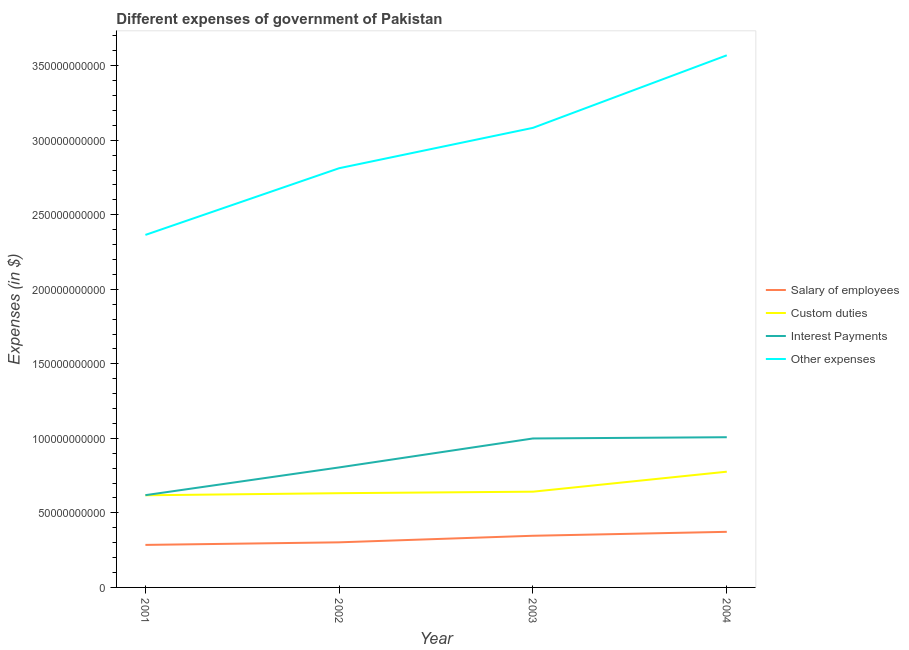How many different coloured lines are there?
Your answer should be very brief. 4. Does the line corresponding to amount spent on custom duties intersect with the line corresponding to amount spent on interest payments?
Provide a succinct answer. No. What is the amount spent on salary of employees in 2002?
Your answer should be very brief. 3.03e+1. Across all years, what is the maximum amount spent on custom duties?
Your answer should be very brief. 7.77e+1. Across all years, what is the minimum amount spent on other expenses?
Provide a short and direct response. 2.37e+11. In which year was the amount spent on other expenses maximum?
Offer a terse response. 2004. In which year was the amount spent on other expenses minimum?
Offer a very short reply. 2001. What is the total amount spent on salary of employees in the graph?
Your answer should be very brief. 1.31e+11. What is the difference between the amount spent on other expenses in 2001 and that in 2002?
Provide a short and direct response. -4.48e+1. What is the difference between the amount spent on other expenses in 2002 and the amount spent on custom duties in 2004?
Offer a terse response. 2.04e+11. What is the average amount spent on salary of employees per year?
Give a very brief answer. 3.27e+1. In the year 2001, what is the difference between the amount spent on other expenses and amount spent on interest payments?
Offer a terse response. 1.75e+11. In how many years, is the amount spent on salary of employees greater than 40000000000 $?
Make the answer very short. 0. What is the ratio of the amount spent on other expenses in 2001 to that in 2002?
Provide a short and direct response. 0.84. Is the amount spent on salary of employees in 2003 less than that in 2004?
Your answer should be very brief. Yes. What is the difference between the highest and the second highest amount spent on interest payments?
Offer a very short reply. 8.32e+08. What is the difference between the highest and the lowest amount spent on interest payments?
Keep it short and to the point. 3.89e+1. Is it the case that in every year, the sum of the amount spent on salary of employees and amount spent on custom duties is greater than the amount spent on interest payments?
Your answer should be very brief. No. Does the amount spent on custom duties monotonically increase over the years?
Provide a short and direct response. Yes. Is the amount spent on interest payments strictly less than the amount spent on custom duties over the years?
Provide a short and direct response. No. How many lines are there?
Offer a terse response. 4. How many years are there in the graph?
Provide a succinct answer. 4. Are the values on the major ticks of Y-axis written in scientific E-notation?
Your response must be concise. No. How many legend labels are there?
Give a very brief answer. 4. How are the legend labels stacked?
Offer a terse response. Vertical. What is the title of the graph?
Your answer should be compact. Different expenses of government of Pakistan. What is the label or title of the X-axis?
Your answer should be very brief. Year. What is the label or title of the Y-axis?
Provide a succinct answer. Expenses (in $). What is the Expenses (in $) of Salary of employees in 2001?
Keep it short and to the point. 2.85e+1. What is the Expenses (in $) of Custom duties in 2001?
Offer a terse response. 6.18e+1. What is the Expenses (in $) in Interest Payments in 2001?
Offer a very short reply. 6.19e+1. What is the Expenses (in $) in Other expenses in 2001?
Your answer should be very brief. 2.37e+11. What is the Expenses (in $) in Salary of employees in 2002?
Make the answer very short. 3.03e+1. What is the Expenses (in $) in Custom duties in 2002?
Your answer should be very brief. 6.32e+1. What is the Expenses (in $) in Interest Payments in 2002?
Make the answer very short. 8.05e+1. What is the Expenses (in $) in Other expenses in 2002?
Your answer should be very brief. 2.81e+11. What is the Expenses (in $) in Salary of employees in 2003?
Offer a terse response. 3.47e+1. What is the Expenses (in $) of Custom duties in 2003?
Your answer should be compact. 6.42e+1. What is the Expenses (in $) in Interest Payments in 2003?
Keep it short and to the point. 9.99e+1. What is the Expenses (in $) of Other expenses in 2003?
Your response must be concise. 3.08e+11. What is the Expenses (in $) of Salary of employees in 2004?
Your answer should be very brief. 3.73e+1. What is the Expenses (in $) of Custom duties in 2004?
Make the answer very short. 7.77e+1. What is the Expenses (in $) of Interest Payments in 2004?
Give a very brief answer. 1.01e+11. What is the Expenses (in $) in Other expenses in 2004?
Offer a terse response. 3.57e+11. Across all years, what is the maximum Expenses (in $) of Salary of employees?
Offer a terse response. 3.73e+1. Across all years, what is the maximum Expenses (in $) of Custom duties?
Give a very brief answer. 7.77e+1. Across all years, what is the maximum Expenses (in $) in Interest Payments?
Give a very brief answer. 1.01e+11. Across all years, what is the maximum Expenses (in $) in Other expenses?
Give a very brief answer. 3.57e+11. Across all years, what is the minimum Expenses (in $) in Salary of employees?
Your response must be concise. 2.85e+1. Across all years, what is the minimum Expenses (in $) in Custom duties?
Give a very brief answer. 6.18e+1. Across all years, what is the minimum Expenses (in $) of Interest Payments?
Your answer should be compact. 6.19e+1. Across all years, what is the minimum Expenses (in $) of Other expenses?
Your answer should be very brief. 2.37e+11. What is the total Expenses (in $) of Salary of employees in the graph?
Your answer should be compact. 1.31e+11. What is the total Expenses (in $) in Custom duties in the graph?
Provide a succinct answer. 2.67e+11. What is the total Expenses (in $) in Interest Payments in the graph?
Keep it short and to the point. 3.43e+11. What is the total Expenses (in $) of Other expenses in the graph?
Your answer should be very brief. 1.18e+12. What is the difference between the Expenses (in $) in Salary of employees in 2001 and that in 2002?
Make the answer very short. -1.73e+09. What is the difference between the Expenses (in $) in Custom duties in 2001 and that in 2002?
Your answer should be very brief. -1.40e+09. What is the difference between the Expenses (in $) in Interest Payments in 2001 and that in 2002?
Provide a succinct answer. -1.86e+1. What is the difference between the Expenses (in $) in Other expenses in 2001 and that in 2002?
Give a very brief answer. -4.48e+1. What is the difference between the Expenses (in $) of Salary of employees in 2001 and that in 2003?
Your response must be concise. -6.14e+09. What is the difference between the Expenses (in $) in Custom duties in 2001 and that in 2003?
Your answer should be very brief. -2.42e+09. What is the difference between the Expenses (in $) of Interest Payments in 2001 and that in 2003?
Your response must be concise. -3.80e+1. What is the difference between the Expenses (in $) of Other expenses in 2001 and that in 2003?
Give a very brief answer. -7.18e+1. What is the difference between the Expenses (in $) in Salary of employees in 2001 and that in 2004?
Ensure brevity in your answer.  -8.78e+09. What is the difference between the Expenses (in $) in Custom duties in 2001 and that in 2004?
Provide a succinct answer. -1.58e+1. What is the difference between the Expenses (in $) in Interest Payments in 2001 and that in 2004?
Your response must be concise. -3.89e+1. What is the difference between the Expenses (in $) in Other expenses in 2001 and that in 2004?
Provide a succinct answer. -1.20e+11. What is the difference between the Expenses (in $) in Salary of employees in 2002 and that in 2003?
Ensure brevity in your answer.  -4.40e+09. What is the difference between the Expenses (in $) in Custom duties in 2002 and that in 2003?
Provide a succinct answer. -1.02e+09. What is the difference between the Expenses (in $) in Interest Payments in 2002 and that in 2003?
Your answer should be very brief. -1.94e+1. What is the difference between the Expenses (in $) in Other expenses in 2002 and that in 2003?
Your answer should be compact. -2.71e+1. What is the difference between the Expenses (in $) in Salary of employees in 2002 and that in 2004?
Your response must be concise. -7.04e+09. What is the difference between the Expenses (in $) in Custom duties in 2002 and that in 2004?
Give a very brief answer. -1.44e+1. What is the difference between the Expenses (in $) of Interest Payments in 2002 and that in 2004?
Provide a succinct answer. -2.03e+1. What is the difference between the Expenses (in $) of Other expenses in 2002 and that in 2004?
Ensure brevity in your answer.  -7.57e+1. What is the difference between the Expenses (in $) of Salary of employees in 2003 and that in 2004?
Your answer should be very brief. -2.64e+09. What is the difference between the Expenses (in $) of Custom duties in 2003 and that in 2004?
Offer a terse response. -1.34e+1. What is the difference between the Expenses (in $) of Interest Payments in 2003 and that in 2004?
Offer a terse response. -8.32e+08. What is the difference between the Expenses (in $) of Other expenses in 2003 and that in 2004?
Provide a short and direct response. -4.87e+1. What is the difference between the Expenses (in $) in Salary of employees in 2001 and the Expenses (in $) in Custom duties in 2002?
Offer a very short reply. -3.47e+1. What is the difference between the Expenses (in $) in Salary of employees in 2001 and the Expenses (in $) in Interest Payments in 2002?
Provide a succinct answer. -5.20e+1. What is the difference between the Expenses (in $) of Salary of employees in 2001 and the Expenses (in $) of Other expenses in 2002?
Your answer should be very brief. -2.53e+11. What is the difference between the Expenses (in $) in Custom duties in 2001 and the Expenses (in $) in Interest Payments in 2002?
Offer a very short reply. -1.87e+1. What is the difference between the Expenses (in $) of Custom duties in 2001 and the Expenses (in $) of Other expenses in 2002?
Give a very brief answer. -2.19e+11. What is the difference between the Expenses (in $) in Interest Payments in 2001 and the Expenses (in $) in Other expenses in 2002?
Give a very brief answer. -2.19e+11. What is the difference between the Expenses (in $) in Salary of employees in 2001 and the Expenses (in $) in Custom duties in 2003?
Your answer should be compact. -3.57e+1. What is the difference between the Expenses (in $) of Salary of employees in 2001 and the Expenses (in $) of Interest Payments in 2003?
Your answer should be compact. -7.14e+1. What is the difference between the Expenses (in $) in Salary of employees in 2001 and the Expenses (in $) in Other expenses in 2003?
Your response must be concise. -2.80e+11. What is the difference between the Expenses (in $) of Custom duties in 2001 and the Expenses (in $) of Interest Payments in 2003?
Offer a very short reply. -3.81e+1. What is the difference between the Expenses (in $) in Custom duties in 2001 and the Expenses (in $) in Other expenses in 2003?
Provide a short and direct response. -2.47e+11. What is the difference between the Expenses (in $) of Interest Payments in 2001 and the Expenses (in $) of Other expenses in 2003?
Your answer should be compact. -2.46e+11. What is the difference between the Expenses (in $) of Salary of employees in 2001 and the Expenses (in $) of Custom duties in 2004?
Provide a short and direct response. -4.91e+1. What is the difference between the Expenses (in $) in Salary of employees in 2001 and the Expenses (in $) in Interest Payments in 2004?
Offer a terse response. -7.22e+1. What is the difference between the Expenses (in $) in Salary of employees in 2001 and the Expenses (in $) in Other expenses in 2004?
Offer a terse response. -3.28e+11. What is the difference between the Expenses (in $) of Custom duties in 2001 and the Expenses (in $) of Interest Payments in 2004?
Offer a terse response. -3.90e+1. What is the difference between the Expenses (in $) of Custom duties in 2001 and the Expenses (in $) of Other expenses in 2004?
Your response must be concise. -2.95e+11. What is the difference between the Expenses (in $) of Interest Payments in 2001 and the Expenses (in $) of Other expenses in 2004?
Ensure brevity in your answer.  -2.95e+11. What is the difference between the Expenses (in $) in Salary of employees in 2002 and the Expenses (in $) in Custom duties in 2003?
Your answer should be very brief. -3.40e+1. What is the difference between the Expenses (in $) of Salary of employees in 2002 and the Expenses (in $) of Interest Payments in 2003?
Ensure brevity in your answer.  -6.97e+1. What is the difference between the Expenses (in $) of Salary of employees in 2002 and the Expenses (in $) of Other expenses in 2003?
Offer a terse response. -2.78e+11. What is the difference between the Expenses (in $) of Custom duties in 2002 and the Expenses (in $) of Interest Payments in 2003?
Offer a terse response. -3.67e+1. What is the difference between the Expenses (in $) in Custom duties in 2002 and the Expenses (in $) in Other expenses in 2003?
Ensure brevity in your answer.  -2.45e+11. What is the difference between the Expenses (in $) in Interest Payments in 2002 and the Expenses (in $) in Other expenses in 2003?
Give a very brief answer. -2.28e+11. What is the difference between the Expenses (in $) of Salary of employees in 2002 and the Expenses (in $) of Custom duties in 2004?
Provide a short and direct response. -4.74e+1. What is the difference between the Expenses (in $) of Salary of employees in 2002 and the Expenses (in $) of Interest Payments in 2004?
Keep it short and to the point. -7.05e+1. What is the difference between the Expenses (in $) in Salary of employees in 2002 and the Expenses (in $) in Other expenses in 2004?
Your response must be concise. -3.27e+11. What is the difference between the Expenses (in $) in Custom duties in 2002 and the Expenses (in $) in Interest Payments in 2004?
Provide a succinct answer. -3.76e+1. What is the difference between the Expenses (in $) of Custom duties in 2002 and the Expenses (in $) of Other expenses in 2004?
Your response must be concise. -2.94e+11. What is the difference between the Expenses (in $) in Interest Payments in 2002 and the Expenses (in $) in Other expenses in 2004?
Ensure brevity in your answer.  -2.76e+11. What is the difference between the Expenses (in $) in Salary of employees in 2003 and the Expenses (in $) in Custom duties in 2004?
Ensure brevity in your answer.  -4.30e+1. What is the difference between the Expenses (in $) in Salary of employees in 2003 and the Expenses (in $) in Interest Payments in 2004?
Your answer should be compact. -6.61e+1. What is the difference between the Expenses (in $) in Salary of employees in 2003 and the Expenses (in $) in Other expenses in 2004?
Offer a very short reply. -3.22e+11. What is the difference between the Expenses (in $) of Custom duties in 2003 and the Expenses (in $) of Interest Payments in 2004?
Keep it short and to the point. -3.65e+1. What is the difference between the Expenses (in $) of Custom duties in 2003 and the Expenses (in $) of Other expenses in 2004?
Provide a succinct answer. -2.93e+11. What is the difference between the Expenses (in $) in Interest Payments in 2003 and the Expenses (in $) in Other expenses in 2004?
Your answer should be very brief. -2.57e+11. What is the average Expenses (in $) of Salary of employees per year?
Keep it short and to the point. 3.27e+1. What is the average Expenses (in $) in Custom duties per year?
Your answer should be very brief. 6.67e+1. What is the average Expenses (in $) in Interest Payments per year?
Your answer should be very brief. 8.58e+1. What is the average Expenses (in $) of Other expenses per year?
Offer a very short reply. 2.96e+11. In the year 2001, what is the difference between the Expenses (in $) in Salary of employees and Expenses (in $) in Custom duties?
Offer a terse response. -3.33e+1. In the year 2001, what is the difference between the Expenses (in $) of Salary of employees and Expenses (in $) of Interest Payments?
Provide a short and direct response. -3.34e+1. In the year 2001, what is the difference between the Expenses (in $) of Salary of employees and Expenses (in $) of Other expenses?
Offer a terse response. -2.08e+11. In the year 2001, what is the difference between the Expenses (in $) in Custom duties and Expenses (in $) in Interest Payments?
Ensure brevity in your answer.  -7.80e+07. In the year 2001, what is the difference between the Expenses (in $) of Custom duties and Expenses (in $) of Other expenses?
Offer a very short reply. -1.75e+11. In the year 2001, what is the difference between the Expenses (in $) in Interest Payments and Expenses (in $) in Other expenses?
Your answer should be very brief. -1.75e+11. In the year 2002, what is the difference between the Expenses (in $) in Salary of employees and Expenses (in $) in Custom duties?
Provide a short and direct response. -3.30e+1. In the year 2002, what is the difference between the Expenses (in $) in Salary of employees and Expenses (in $) in Interest Payments?
Provide a short and direct response. -5.03e+1. In the year 2002, what is the difference between the Expenses (in $) of Salary of employees and Expenses (in $) of Other expenses?
Give a very brief answer. -2.51e+11. In the year 2002, what is the difference between the Expenses (in $) in Custom duties and Expenses (in $) in Interest Payments?
Offer a very short reply. -1.73e+1. In the year 2002, what is the difference between the Expenses (in $) in Custom duties and Expenses (in $) in Other expenses?
Offer a very short reply. -2.18e+11. In the year 2002, what is the difference between the Expenses (in $) of Interest Payments and Expenses (in $) of Other expenses?
Offer a terse response. -2.01e+11. In the year 2003, what is the difference between the Expenses (in $) of Salary of employees and Expenses (in $) of Custom duties?
Provide a short and direct response. -2.96e+1. In the year 2003, what is the difference between the Expenses (in $) of Salary of employees and Expenses (in $) of Interest Payments?
Give a very brief answer. -6.53e+1. In the year 2003, what is the difference between the Expenses (in $) in Salary of employees and Expenses (in $) in Other expenses?
Give a very brief answer. -2.74e+11. In the year 2003, what is the difference between the Expenses (in $) of Custom duties and Expenses (in $) of Interest Payments?
Make the answer very short. -3.57e+1. In the year 2003, what is the difference between the Expenses (in $) in Custom duties and Expenses (in $) in Other expenses?
Offer a terse response. -2.44e+11. In the year 2003, what is the difference between the Expenses (in $) in Interest Payments and Expenses (in $) in Other expenses?
Your answer should be very brief. -2.08e+11. In the year 2004, what is the difference between the Expenses (in $) in Salary of employees and Expenses (in $) in Custom duties?
Your response must be concise. -4.03e+1. In the year 2004, what is the difference between the Expenses (in $) of Salary of employees and Expenses (in $) of Interest Payments?
Give a very brief answer. -6.35e+1. In the year 2004, what is the difference between the Expenses (in $) in Salary of employees and Expenses (in $) in Other expenses?
Provide a succinct answer. -3.20e+11. In the year 2004, what is the difference between the Expenses (in $) of Custom duties and Expenses (in $) of Interest Payments?
Your response must be concise. -2.31e+1. In the year 2004, what is the difference between the Expenses (in $) in Custom duties and Expenses (in $) in Other expenses?
Make the answer very short. -2.79e+11. In the year 2004, what is the difference between the Expenses (in $) of Interest Payments and Expenses (in $) of Other expenses?
Keep it short and to the point. -2.56e+11. What is the ratio of the Expenses (in $) in Salary of employees in 2001 to that in 2002?
Ensure brevity in your answer.  0.94. What is the ratio of the Expenses (in $) of Custom duties in 2001 to that in 2002?
Keep it short and to the point. 0.98. What is the ratio of the Expenses (in $) of Interest Payments in 2001 to that in 2002?
Your answer should be compact. 0.77. What is the ratio of the Expenses (in $) in Other expenses in 2001 to that in 2002?
Ensure brevity in your answer.  0.84. What is the ratio of the Expenses (in $) of Salary of employees in 2001 to that in 2003?
Ensure brevity in your answer.  0.82. What is the ratio of the Expenses (in $) of Custom duties in 2001 to that in 2003?
Your response must be concise. 0.96. What is the ratio of the Expenses (in $) in Interest Payments in 2001 to that in 2003?
Keep it short and to the point. 0.62. What is the ratio of the Expenses (in $) of Other expenses in 2001 to that in 2003?
Give a very brief answer. 0.77. What is the ratio of the Expenses (in $) of Salary of employees in 2001 to that in 2004?
Your answer should be very brief. 0.76. What is the ratio of the Expenses (in $) in Custom duties in 2001 to that in 2004?
Offer a very short reply. 0.8. What is the ratio of the Expenses (in $) in Interest Payments in 2001 to that in 2004?
Give a very brief answer. 0.61. What is the ratio of the Expenses (in $) of Other expenses in 2001 to that in 2004?
Ensure brevity in your answer.  0.66. What is the ratio of the Expenses (in $) of Salary of employees in 2002 to that in 2003?
Your response must be concise. 0.87. What is the ratio of the Expenses (in $) in Custom duties in 2002 to that in 2003?
Offer a terse response. 0.98. What is the ratio of the Expenses (in $) of Interest Payments in 2002 to that in 2003?
Your response must be concise. 0.81. What is the ratio of the Expenses (in $) of Other expenses in 2002 to that in 2003?
Your response must be concise. 0.91. What is the ratio of the Expenses (in $) in Salary of employees in 2002 to that in 2004?
Provide a short and direct response. 0.81. What is the ratio of the Expenses (in $) in Custom duties in 2002 to that in 2004?
Give a very brief answer. 0.81. What is the ratio of the Expenses (in $) in Interest Payments in 2002 to that in 2004?
Make the answer very short. 0.8. What is the ratio of the Expenses (in $) in Other expenses in 2002 to that in 2004?
Make the answer very short. 0.79. What is the ratio of the Expenses (in $) of Salary of employees in 2003 to that in 2004?
Your response must be concise. 0.93. What is the ratio of the Expenses (in $) in Custom duties in 2003 to that in 2004?
Your response must be concise. 0.83. What is the ratio of the Expenses (in $) in Other expenses in 2003 to that in 2004?
Your answer should be compact. 0.86. What is the difference between the highest and the second highest Expenses (in $) of Salary of employees?
Offer a very short reply. 2.64e+09. What is the difference between the highest and the second highest Expenses (in $) in Custom duties?
Your answer should be compact. 1.34e+1. What is the difference between the highest and the second highest Expenses (in $) of Interest Payments?
Provide a succinct answer. 8.32e+08. What is the difference between the highest and the second highest Expenses (in $) in Other expenses?
Your answer should be compact. 4.87e+1. What is the difference between the highest and the lowest Expenses (in $) in Salary of employees?
Keep it short and to the point. 8.78e+09. What is the difference between the highest and the lowest Expenses (in $) in Custom duties?
Offer a terse response. 1.58e+1. What is the difference between the highest and the lowest Expenses (in $) of Interest Payments?
Keep it short and to the point. 3.89e+1. What is the difference between the highest and the lowest Expenses (in $) of Other expenses?
Give a very brief answer. 1.20e+11. 